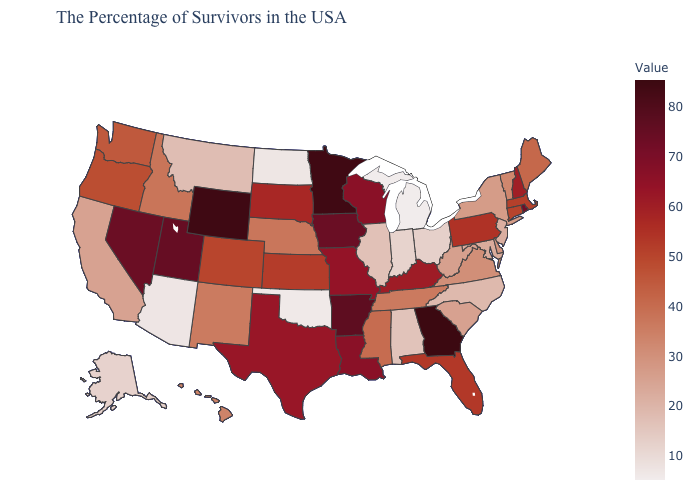Does Maryland have a lower value than Wisconsin?
Answer briefly. Yes. Which states hav the highest value in the MidWest?
Concise answer only. Minnesota. Among the states that border Virginia , does Maryland have the highest value?
Answer briefly. No. Does Nebraska have a lower value than Arizona?
Answer briefly. No. Among the states that border Pennsylvania , does Delaware have the highest value?
Keep it brief. Yes. Does Georgia have the highest value in the USA?
Give a very brief answer. Yes. Among the states that border California , does Oregon have the highest value?
Keep it brief. No. 